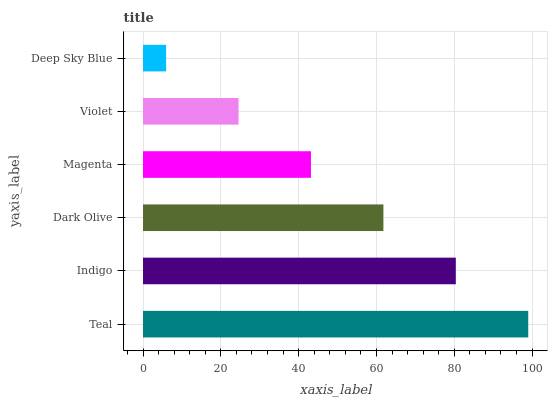Is Deep Sky Blue the minimum?
Answer yes or no. Yes. Is Teal the maximum?
Answer yes or no. Yes. Is Indigo the minimum?
Answer yes or no. No. Is Indigo the maximum?
Answer yes or no. No. Is Teal greater than Indigo?
Answer yes or no. Yes. Is Indigo less than Teal?
Answer yes or no. Yes. Is Indigo greater than Teal?
Answer yes or no. No. Is Teal less than Indigo?
Answer yes or no. No. Is Dark Olive the high median?
Answer yes or no. Yes. Is Magenta the low median?
Answer yes or no. Yes. Is Violet the high median?
Answer yes or no. No. Is Deep Sky Blue the low median?
Answer yes or no. No. 